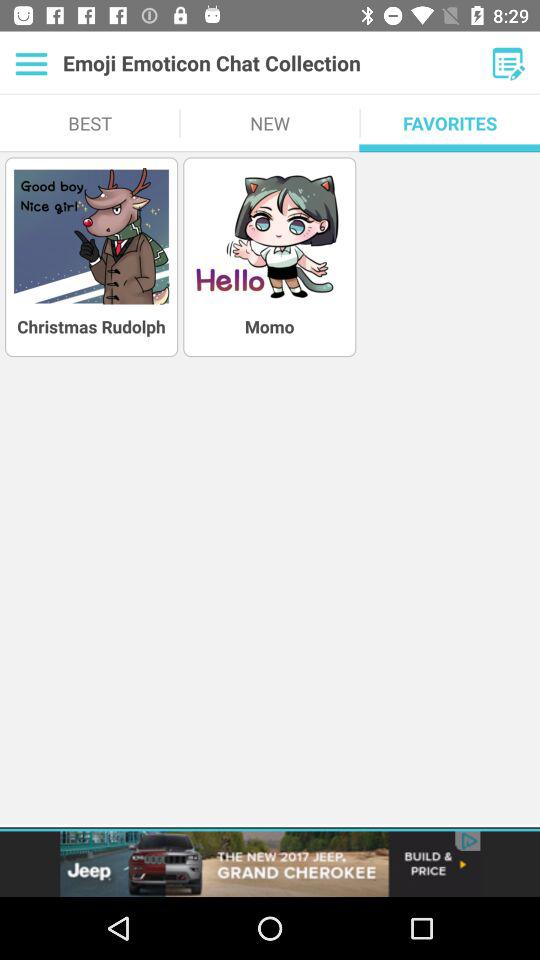What is the application name? The application name is "Emoji Emoticon Chat Collection". 